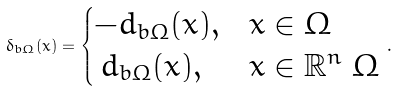Convert formula to latex. <formula><loc_0><loc_0><loc_500><loc_500>\delta _ { b \Omega } ( x ) = \begin{cases} - d _ { b \Omega } ( x ) , & x \in \Omega \\ \, d _ { b \Omega } ( x ) , & x \in \mathbb { R } ^ { n } \ \Omega \end{cases} \, .</formula> 